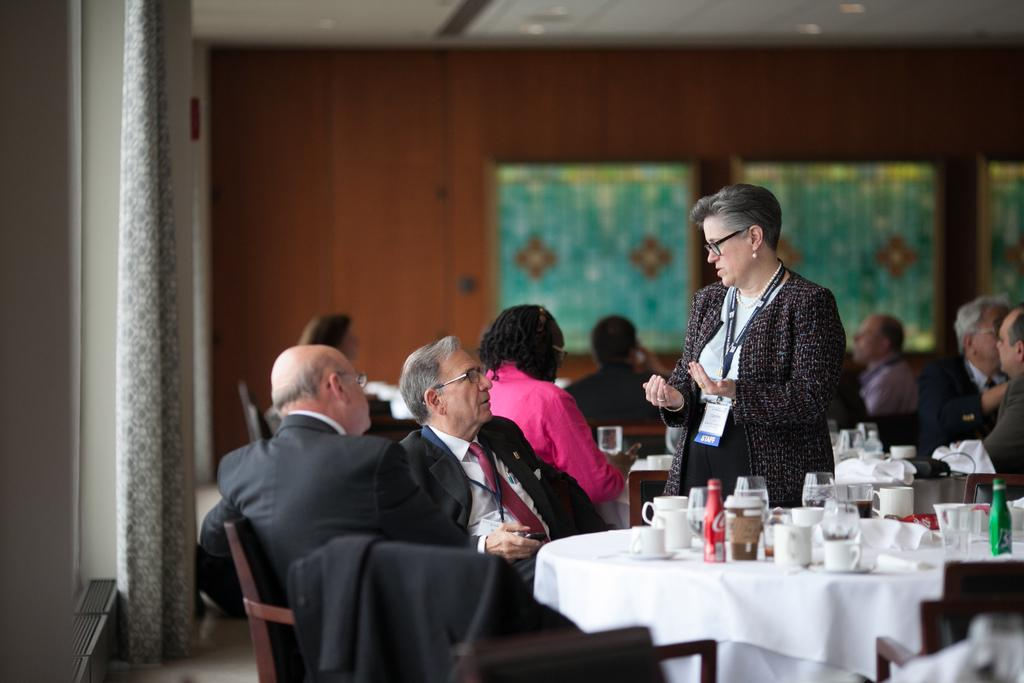What are the people in the image doing? The people in the image are sitting on chairs. Are there any other people in the image besides those sitting on chairs? Yes, there is a person standing in the image. What type of stick is the crow holding in the image? There is no stick or crow present in the image. 